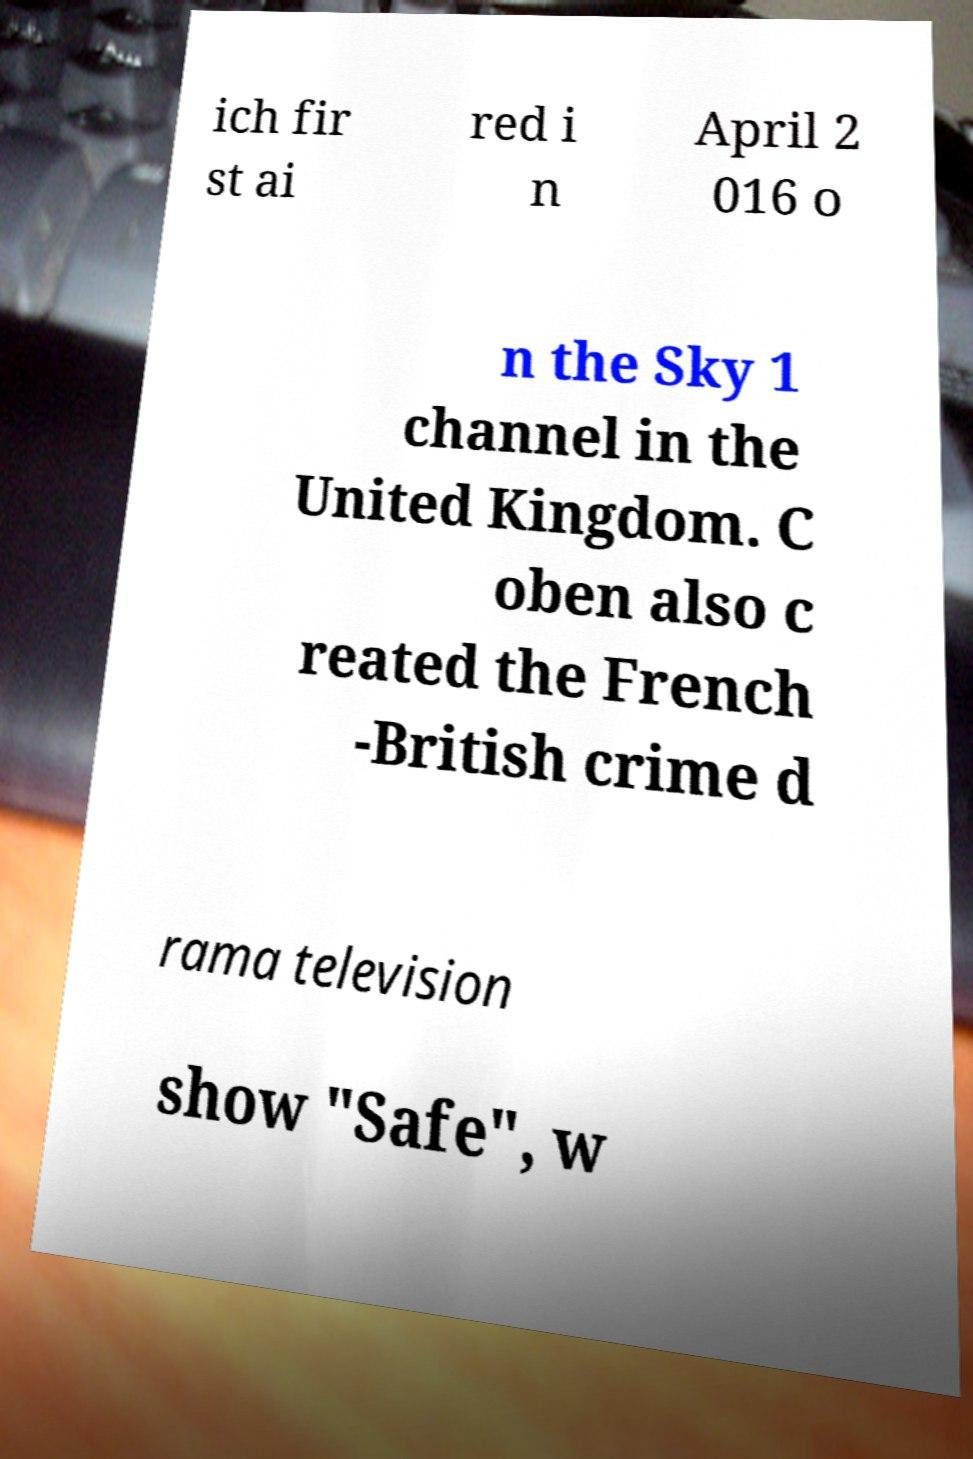Can you read and provide the text displayed in the image?This photo seems to have some interesting text. Can you extract and type it out for me? ich fir st ai red i n April 2 016 o n the Sky 1 channel in the United Kingdom. C oben also c reated the French -British crime d rama television show "Safe", w 